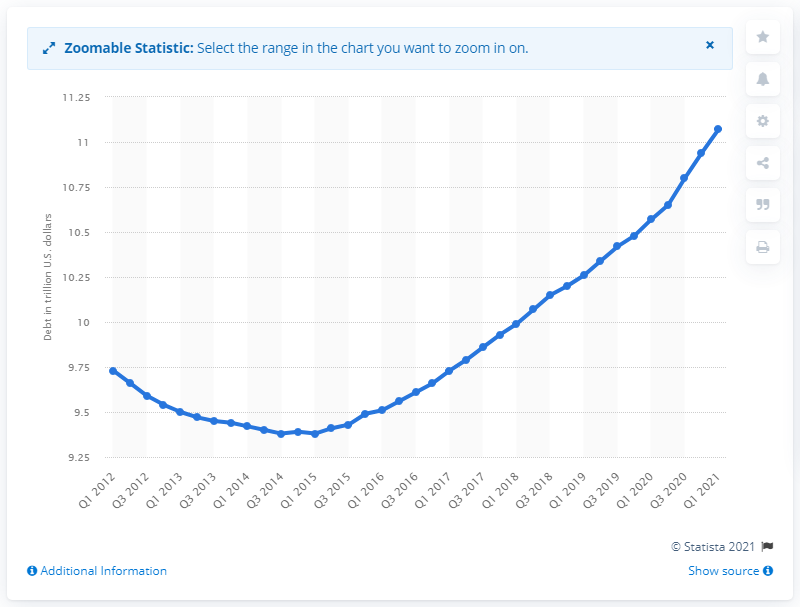Give some essential details in this illustration. The debt of home mortgages in the first quarter of 2021 was $11.07. 